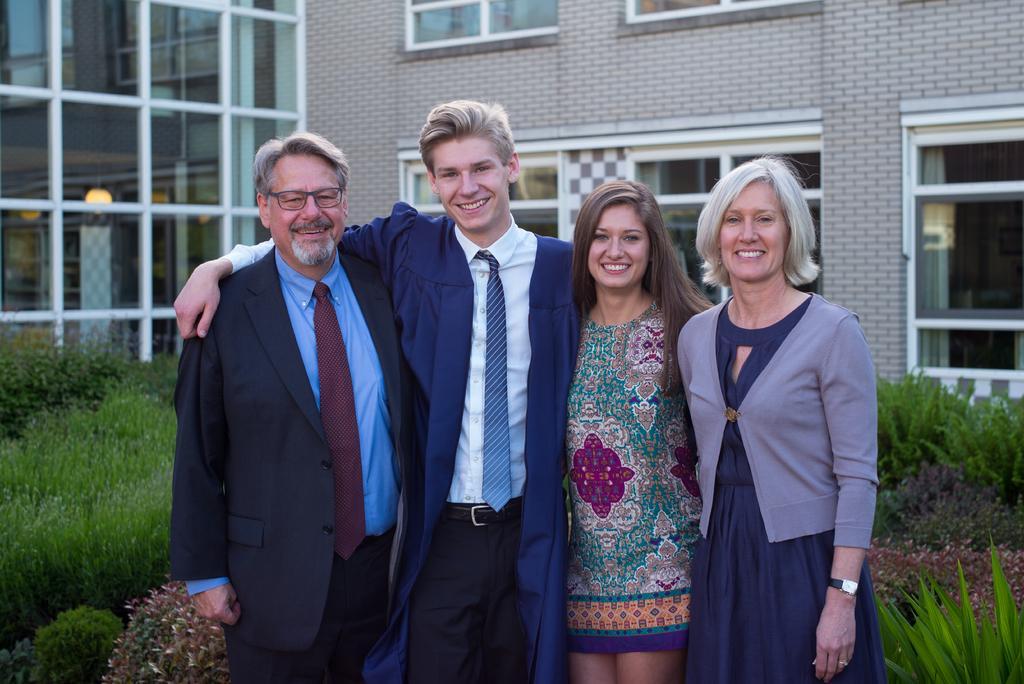Describe this image in one or two sentences. In this image I can see in the middle two men are standing, they are wearing coats, ties, shirts. Beside them two girls are also standing, they are smiling, behind them there are bushes and there is a building with glasses. 